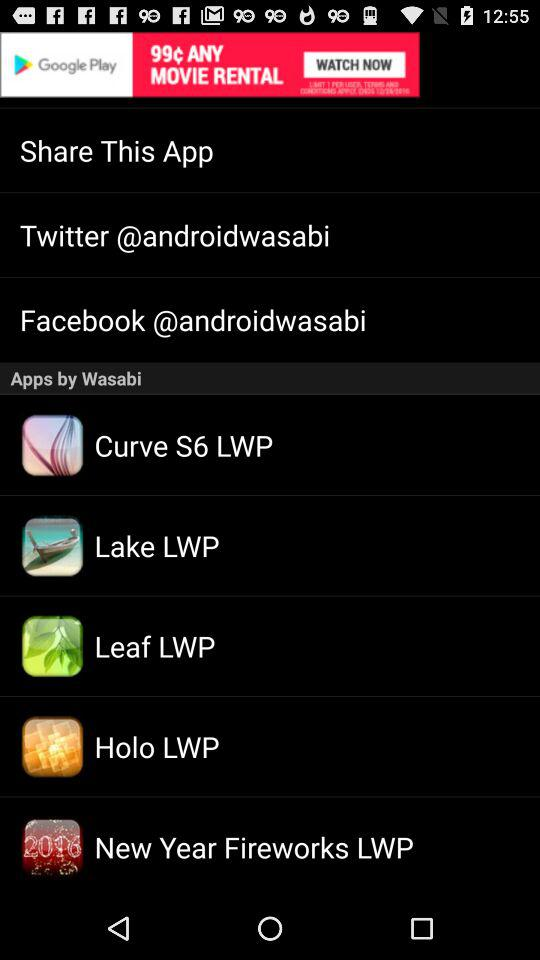What is the user name for Twitter? The user name is androidwasabi. 